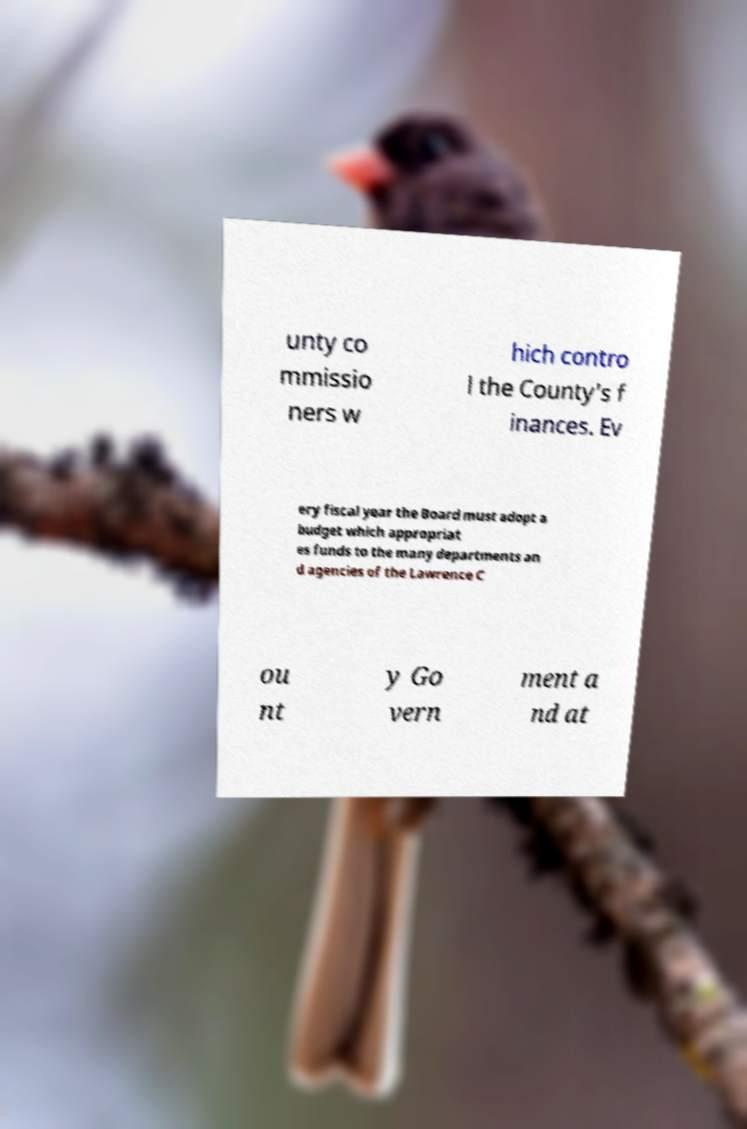For documentation purposes, I need the text within this image transcribed. Could you provide that? unty co mmissio ners w hich contro l the County's f inances. Ev ery fiscal year the Board must adopt a budget which appropriat es funds to the many departments an d agencies of the Lawrence C ou nt y Go vern ment a nd at 